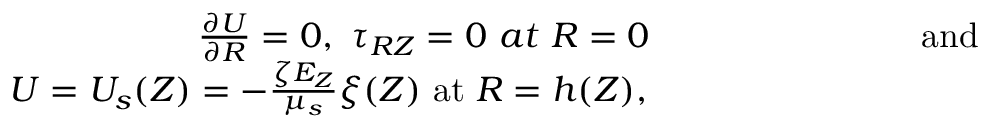Convert formula to latex. <formula><loc_0><loc_0><loc_500><loc_500>\begin{array} { r } { \frac { \partial U } { \partial R } = 0 , \tau _ { R Z } = 0 a t R = 0 a n d } \\ { U = U _ { s } ( Z ) = - \frac { \zeta E _ { Z } } { \mu _ { s } } \xi ( Z ) a t R = h ( Z ) , } \end{array}</formula> 